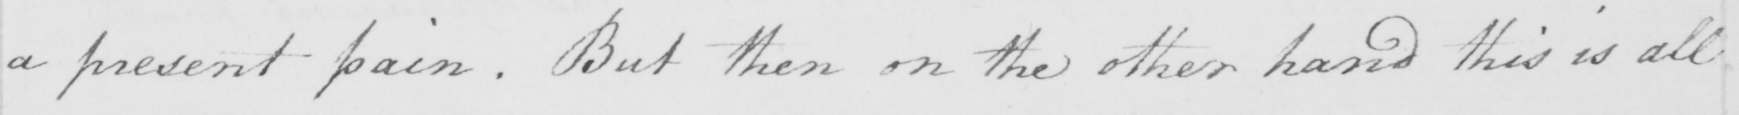Transcribe the text shown in this historical manuscript line. a present pain . But then on the other hand this is all 